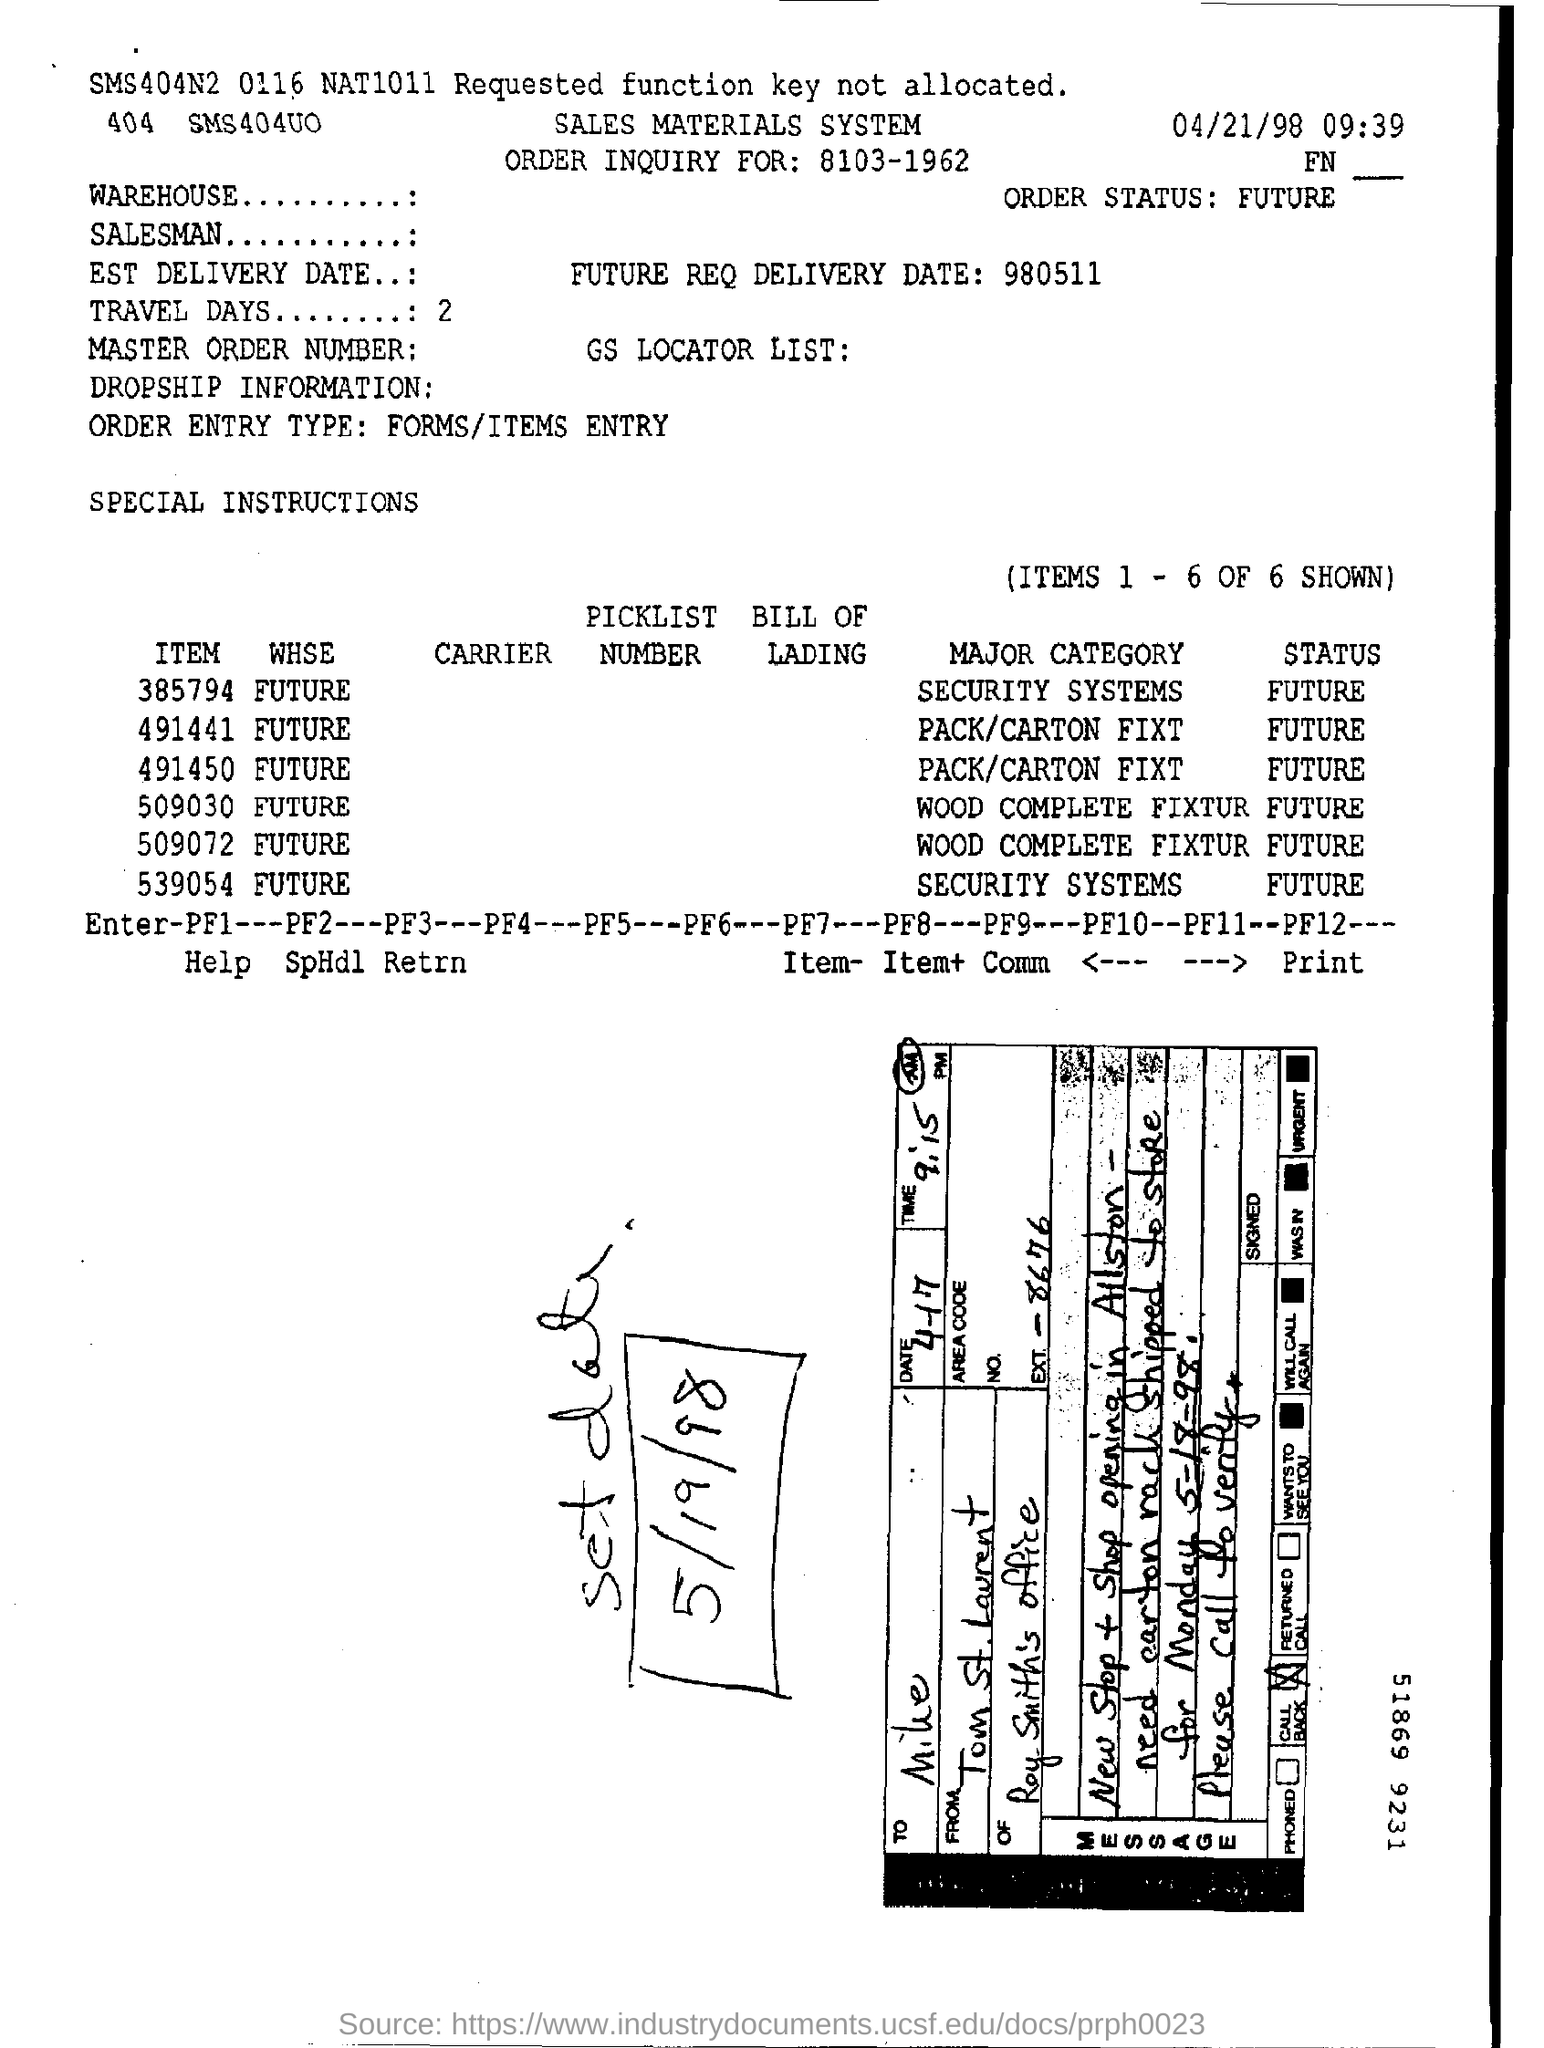Outline some significant characteristics in this image. The time mentioned along with the date at the right top corner of the page is 09:39. The status of item number 509030 is FUTURE. There are provided 2 TRAVEL DAYS. What is the ORDER STATUS?" is a question asking for information about the current status of an order. The major category of item number 509030 is wood complete fixtures and cabinets. 